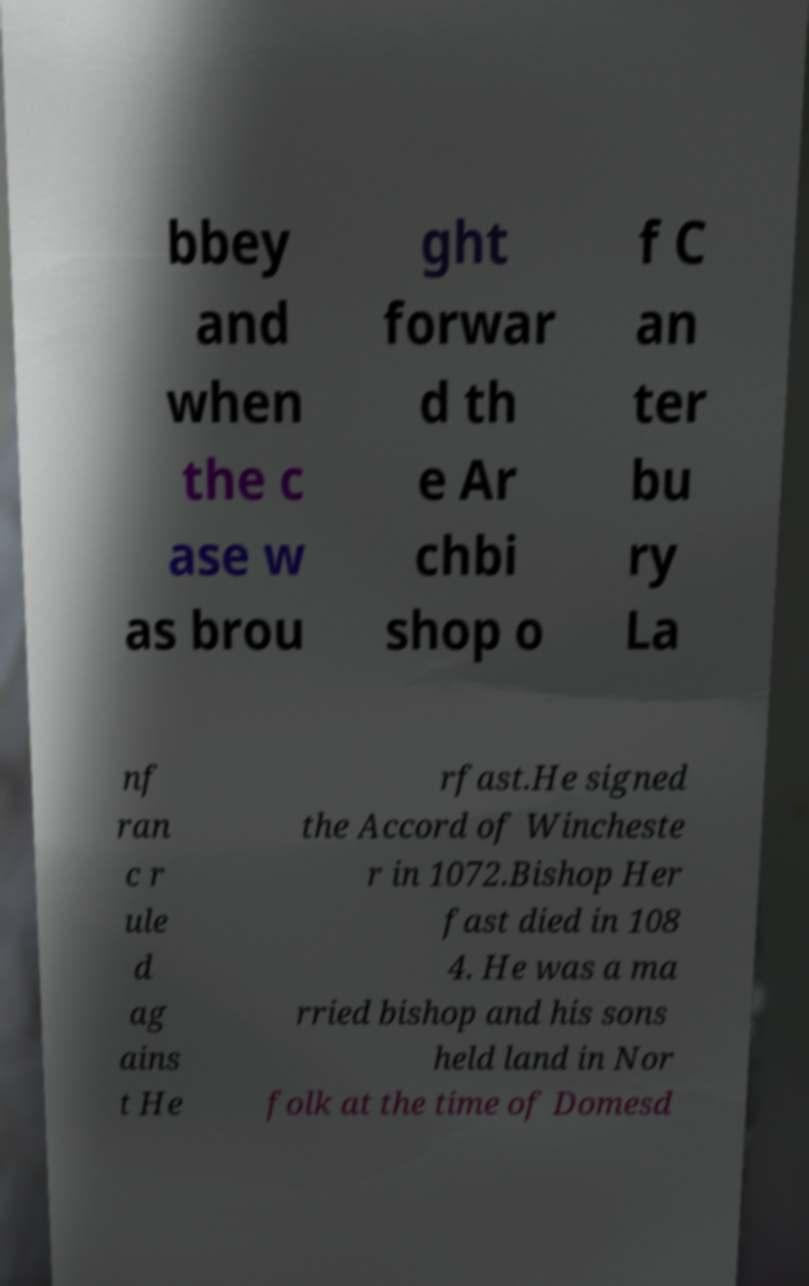Could you extract and type out the text from this image? bbey and when the c ase w as brou ght forwar d th e Ar chbi shop o f C an ter bu ry La nf ran c r ule d ag ains t He rfast.He signed the Accord of Wincheste r in 1072.Bishop Her fast died in 108 4. He was a ma rried bishop and his sons held land in Nor folk at the time of Domesd 